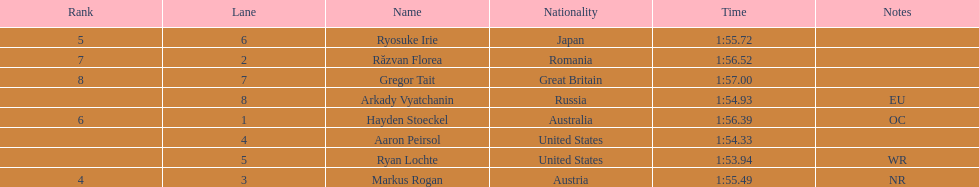Which competitor was the last to place? Gregor Tait. 